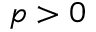<formula> <loc_0><loc_0><loc_500><loc_500>p > 0</formula> 